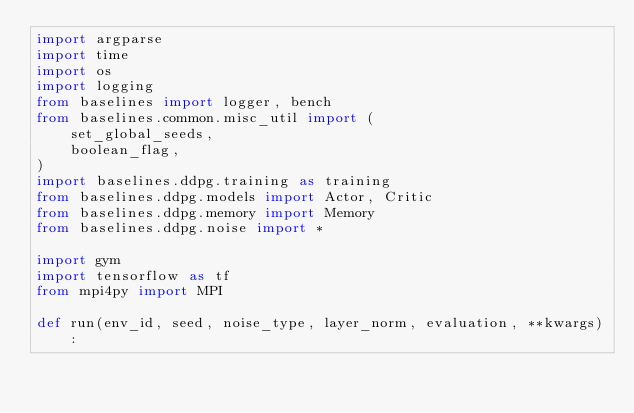<code> <loc_0><loc_0><loc_500><loc_500><_Python_>import argparse
import time
import os
import logging
from baselines import logger, bench
from baselines.common.misc_util import (
    set_global_seeds,
    boolean_flag,
)
import baselines.ddpg.training as training
from baselines.ddpg.models import Actor, Critic
from baselines.ddpg.memory import Memory
from baselines.ddpg.noise import *

import gym
import tensorflow as tf
from mpi4py import MPI

def run(env_id, seed, noise_type, layer_norm, evaluation, **kwargs):</code> 